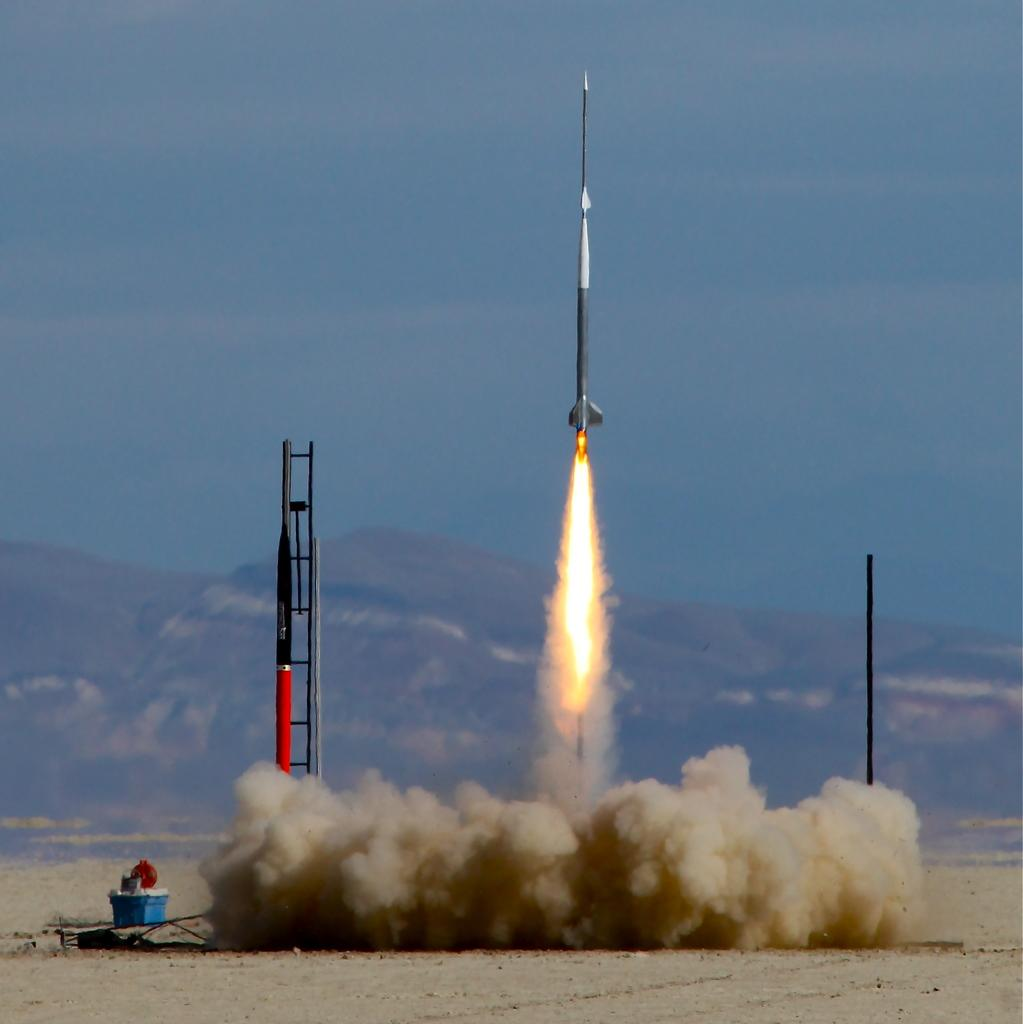What is the main subject of the picture? The main subject of the picture is a rocket launcher. What is associated with the rocket launcher in the picture? There is a missile in the picture. What can be seen in the background of the picture? There is a mountain in the background of the picture. How would you describe the sky in the picture? The sky is clear in the picture. What type of zipper can be seen on the rocket launcher in the image? There is no zipper present on the rocket launcher in the image. Is there a stove visible in the picture? There is no stove present in the image. 